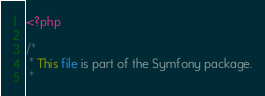<code> <loc_0><loc_0><loc_500><loc_500><_PHP_><?php

/*
 * This file is part of the Symfony package.
 *</code> 